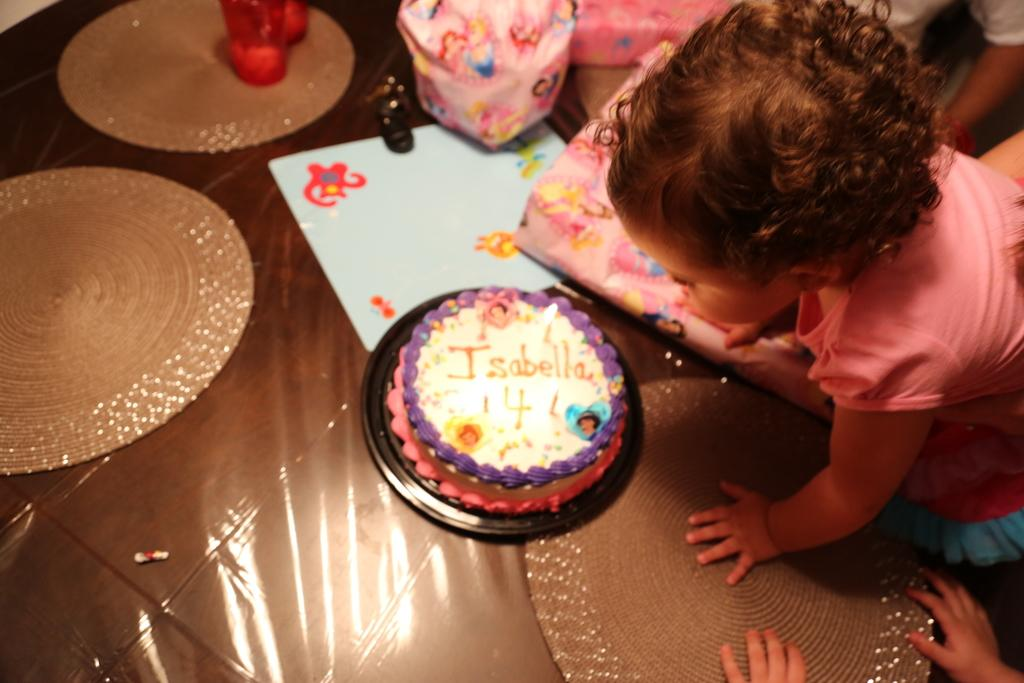What is the main subject of the image? There is a cake in the image. What can be seen on the floor in the image? There are objects on the brown color floor. Can you describe the child in the image? There is a child wearing a pink dress in the image. What is visible in the background of the image? There are people visible in the background of the image. How many tomatoes are on the cake in the image? There are no tomatoes present on the cake in the image. What advice does the grandfather give to the child in the image? There is no grandfather present in the image, so it is not possible to answer that question. 